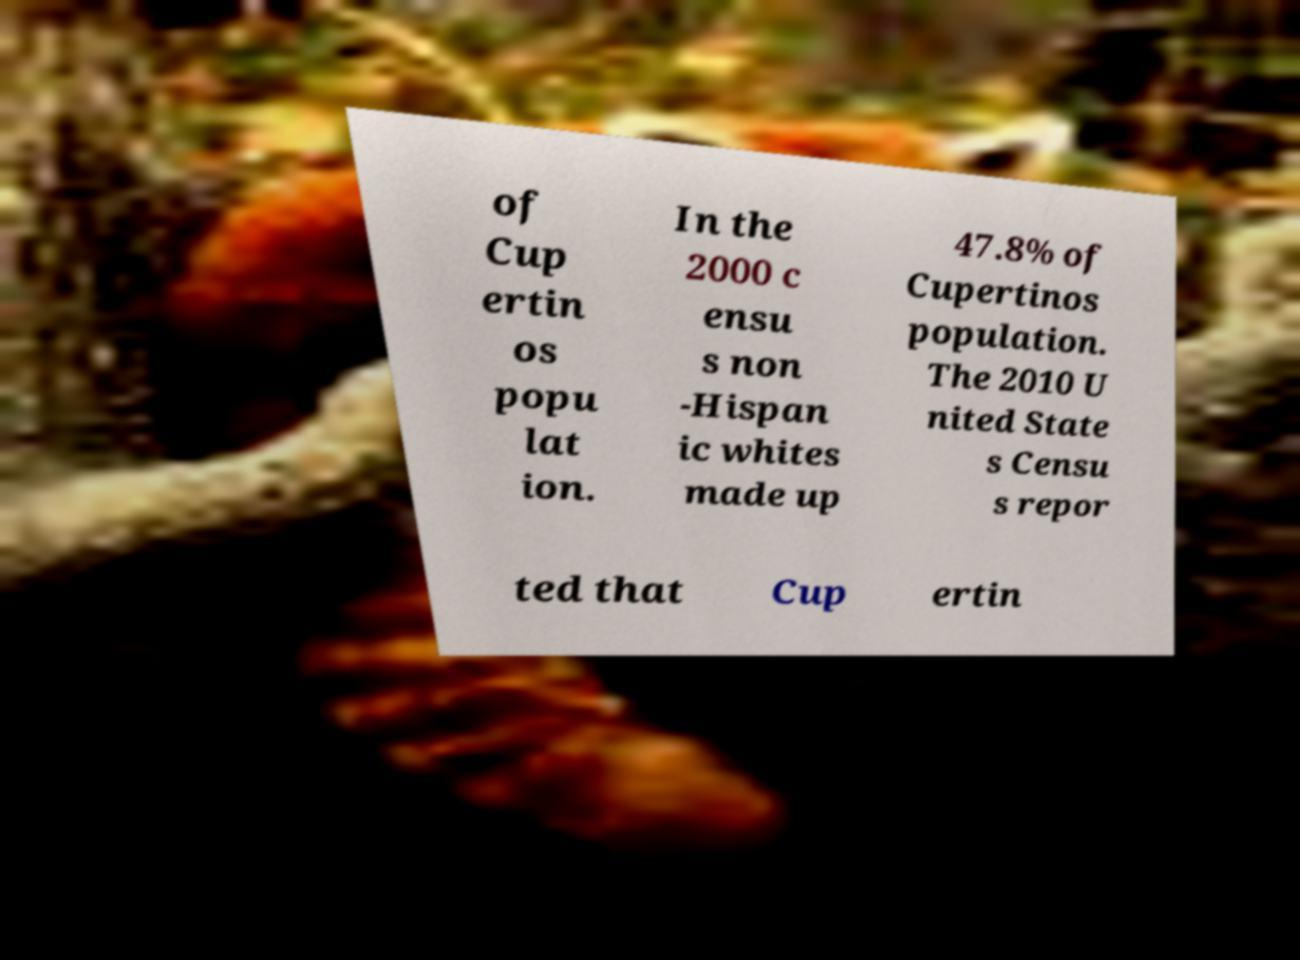Please read and relay the text visible in this image. What does it say? of Cup ertin os popu lat ion. In the 2000 c ensu s non -Hispan ic whites made up 47.8% of Cupertinos population. The 2010 U nited State s Censu s repor ted that Cup ertin 